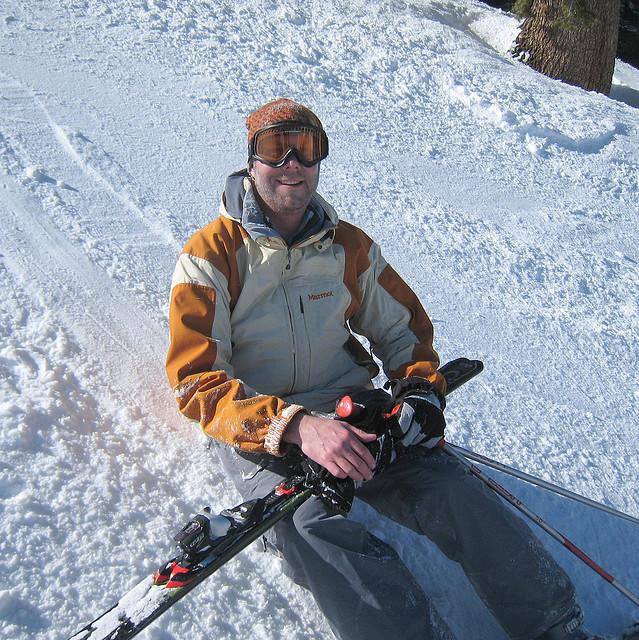What color are the lenses of his goggles?
Quick response, please. Orange. Is the man on the floor?
Keep it brief. No. How many gloves is he wearing?
Short answer required. 1. 